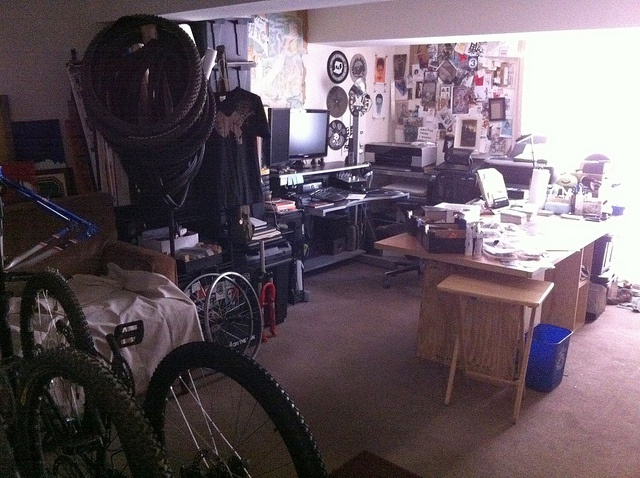Describe the objects in this image and their specific colors. I can see bicycle in black and gray tones, bicycle in black and gray tones, tv in black, lavender, purple, navy, and darkgray tones, chair in black and purple tones, and chair in black and purple tones in this image. 